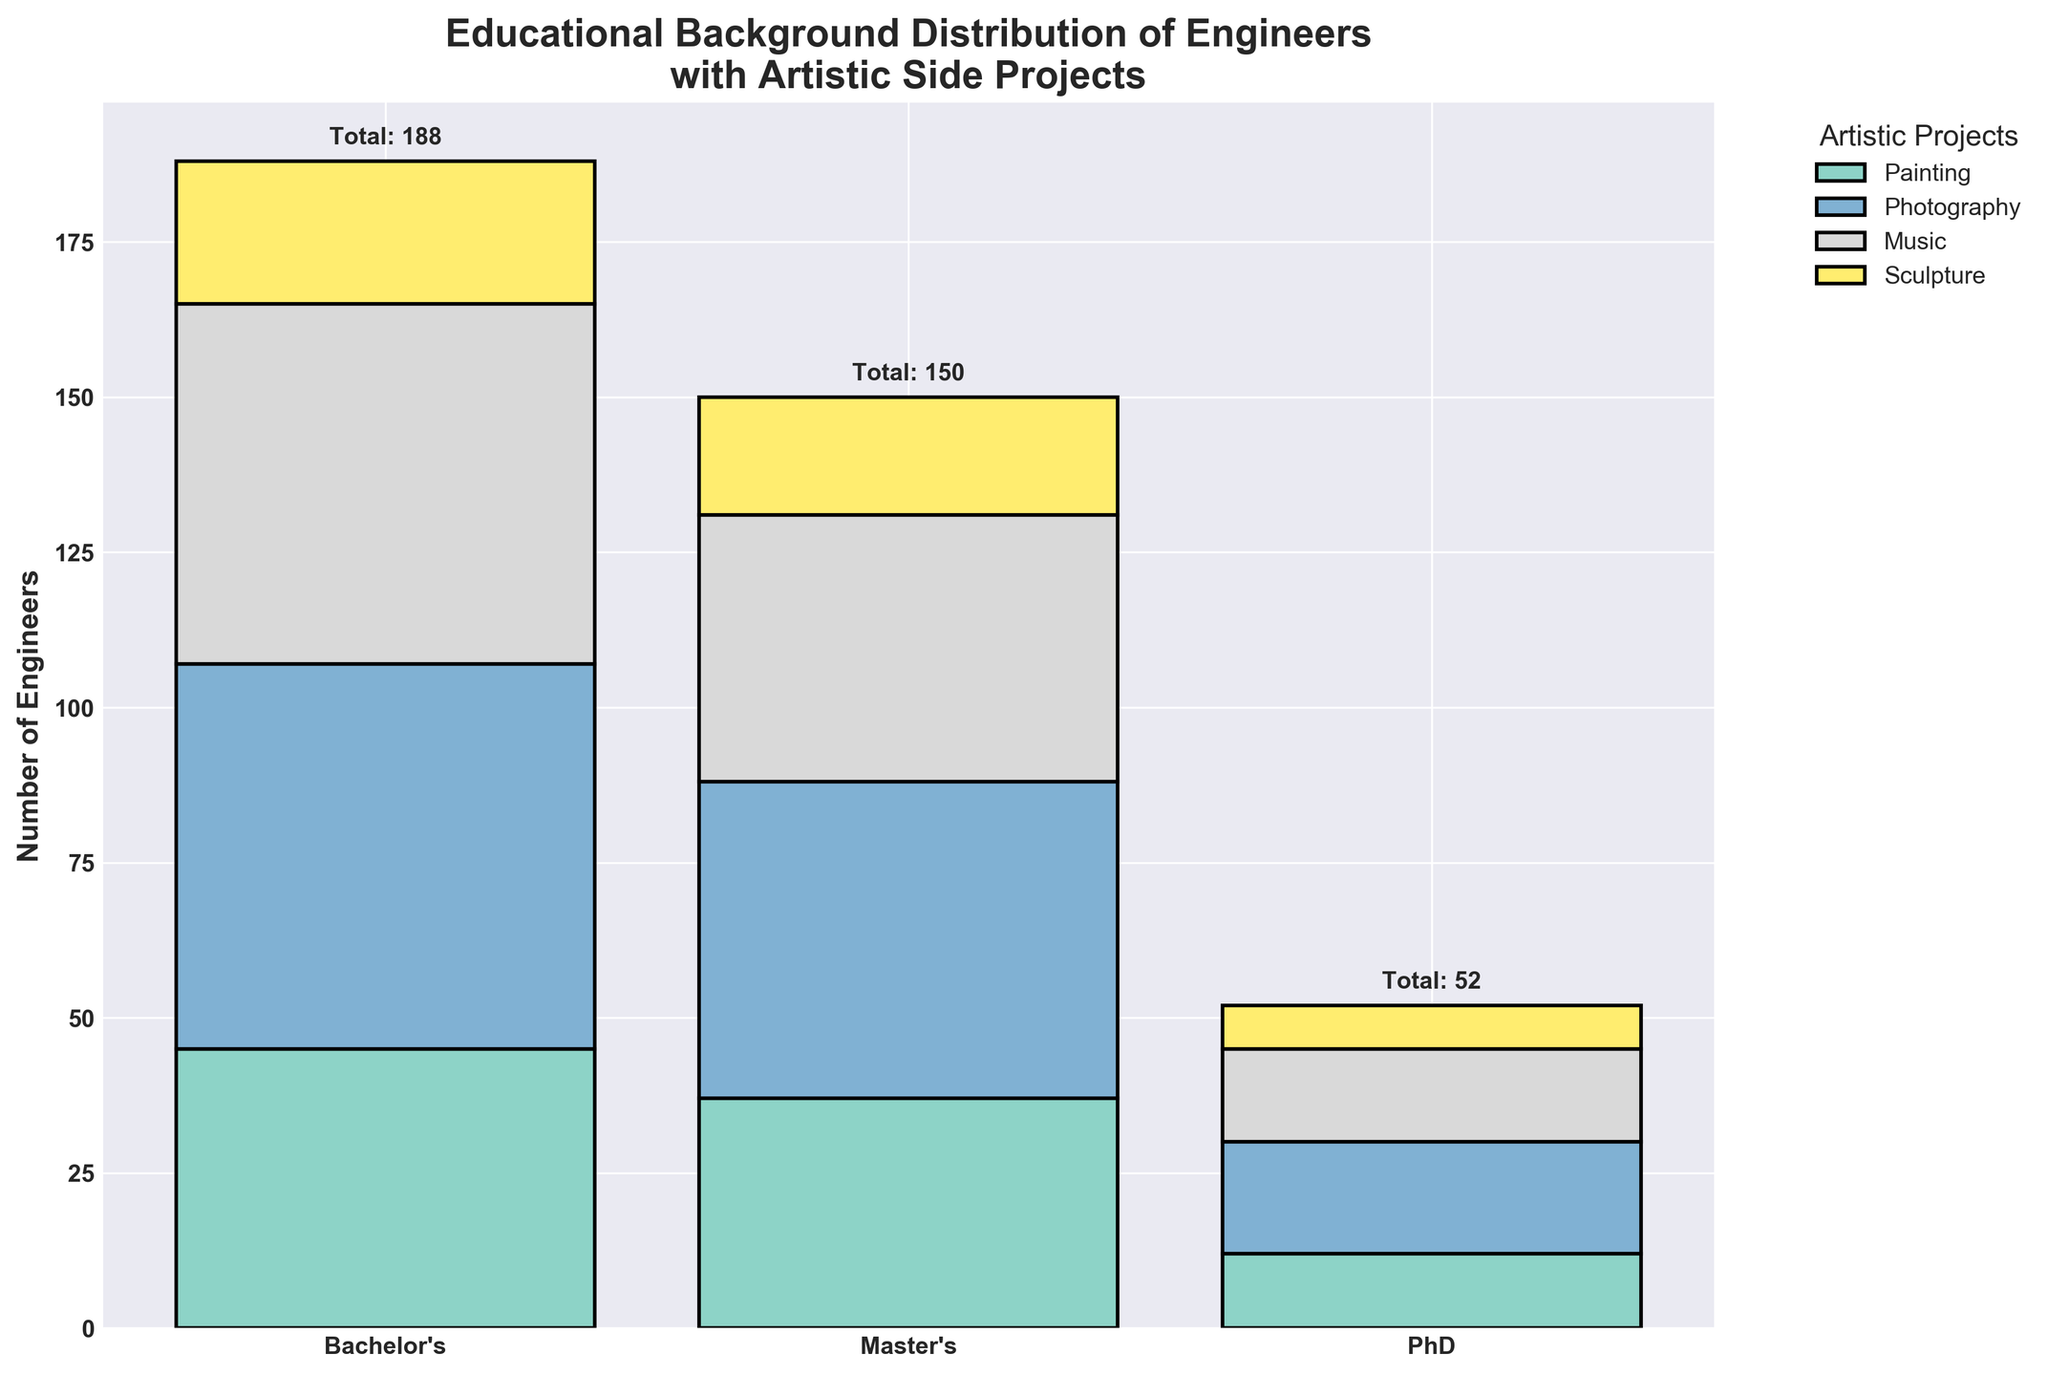What's the title of the figure? The title is normally found at the top of the figure; here, it should describe the context of the data being visualized. The title is "Educational Background Distribution of Engineers with Artistic Side Projects."
Answer: Educational Background Distribution of Engineers with Artistic Side Projects What is the total number of engineers with a Bachelor’s degree involved in artistic side projects? Sum up the counts for each artistic side project for engineers with a Bachelor’s degree (45 + 62 + 58 + 23). This amounts to 188.
Answer: 188 Which artistic side project has the highest number of engineers involved who have a Master's degree? Check the counts for each artistic side project (Painting, Photography, Music, Sculpture) and find the highest count. Photography has the highest count at 51.
Answer: Photography How many engineers with a PhD are involved in Sculpture projects? Look at the bar segment corresponding to engineers with a PhD involved in Sculpture projects. The count is 7.
Answer: 7 What is the combined total number of engineers involved in Painting and Sculpture projects? Add up the counts of engineers involved in Painting (45 + 37 + 12) and Sculpture (23 + 19 + 7). The total is 143.
Answer: 143 Which education level has the least number of engineers with artistic side projects? Compare the total counts for each education level (Bachelor's, Master's, PhD). PhD has the smallest total number, calculated as 12 + 18 + 15 + 7 = 52.
Answer: PhD What is the percentage of engineers with a Master’s degree involved in artistic side projects that are Painting? Calculate the proportion by dividing the number of Master's degree engineers in Painting (37) by the total number of Master's degree engineers (37 + 51 + 43 + 19 = 150) and multiply by 100. The percentage is approximately 24.67%.
Answer: 24.67% How does the total number of engineers involved in Music compare across the three education levels? Compare the counts for engineers in Music for Bachelor's (58), Master's (43), and PhD (15). Bachelor's has the most, followed by Master's, then PhD.
Answer: Bachelor's > Master's > PhD What is the difference in the number of engineers with Photography projects between those with a Bachelor's and a PhD? Subtract the number of PhD engineers in Photography (18) from the number of Bachelor's engineers in Photography (62). The difference is 44.
Answer: 44 